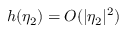<formula> <loc_0><loc_0><loc_500><loc_500>h ( \eta _ { 2 } ) = O ( | \eta _ { 2 } | ^ { 2 } )</formula> 